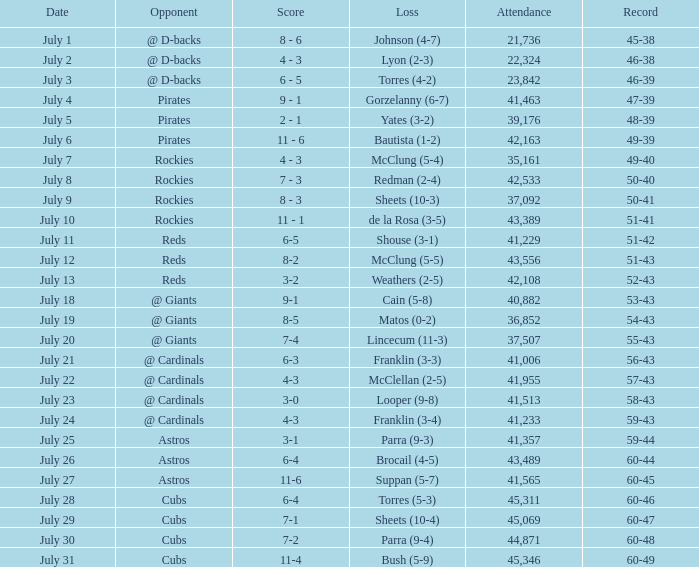What's the presence of the game where there was a loss of yates (3-2)? 39176.0. Would you mind parsing the complete table? {'header': ['Date', 'Opponent', 'Score', 'Loss', 'Attendance', 'Record'], 'rows': [['July 1', '@ D-backs', '8 - 6', 'Johnson (4-7)', '21,736', '45-38'], ['July 2', '@ D-backs', '4 - 3', 'Lyon (2-3)', '22,324', '46-38'], ['July 3', '@ D-backs', '6 - 5', 'Torres (4-2)', '23,842', '46-39'], ['July 4', 'Pirates', '9 - 1', 'Gorzelanny (6-7)', '41,463', '47-39'], ['July 5', 'Pirates', '2 - 1', 'Yates (3-2)', '39,176', '48-39'], ['July 6', 'Pirates', '11 - 6', 'Bautista (1-2)', '42,163', '49-39'], ['July 7', 'Rockies', '4 - 3', 'McClung (5-4)', '35,161', '49-40'], ['July 8', 'Rockies', '7 - 3', 'Redman (2-4)', '42,533', '50-40'], ['July 9', 'Rockies', '8 - 3', 'Sheets (10-3)', '37,092', '50-41'], ['July 10', 'Rockies', '11 - 1', 'de la Rosa (3-5)', '43,389', '51-41'], ['July 11', 'Reds', '6-5', 'Shouse (3-1)', '41,229', '51-42'], ['July 12', 'Reds', '8-2', 'McClung (5-5)', '43,556', '51-43'], ['July 13', 'Reds', '3-2', 'Weathers (2-5)', '42,108', '52-43'], ['July 18', '@ Giants', '9-1', 'Cain (5-8)', '40,882', '53-43'], ['July 19', '@ Giants', '8-5', 'Matos (0-2)', '36,852', '54-43'], ['July 20', '@ Giants', '7-4', 'Lincecum (11-3)', '37,507', '55-43'], ['July 21', '@ Cardinals', '6-3', 'Franklin (3-3)', '41,006', '56-43'], ['July 22', '@ Cardinals', '4-3', 'McClellan (2-5)', '41,955', '57-43'], ['July 23', '@ Cardinals', '3-0', 'Looper (9-8)', '41,513', '58-43'], ['July 24', '@ Cardinals', '4-3', 'Franklin (3-4)', '41,233', '59-43'], ['July 25', 'Astros', '3-1', 'Parra (9-3)', '41,357', '59-44'], ['July 26', 'Astros', '6-4', 'Brocail (4-5)', '43,489', '60-44'], ['July 27', 'Astros', '11-6', 'Suppan (5-7)', '41,565', '60-45'], ['July 28', 'Cubs', '6-4', 'Torres (5-3)', '45,311', '60-46'], ['July 29', 'Cubs', '7-1', 'Sheets (10-4)', '45,069', '60-47'], ['July 30', 'Cubs', '7-2', 'Parra (9-4)', '44,871', '60-48'], ['July 31', 'Cubs', '11-4', 'Bush (5-9)', '45,346', '60-49']]} 